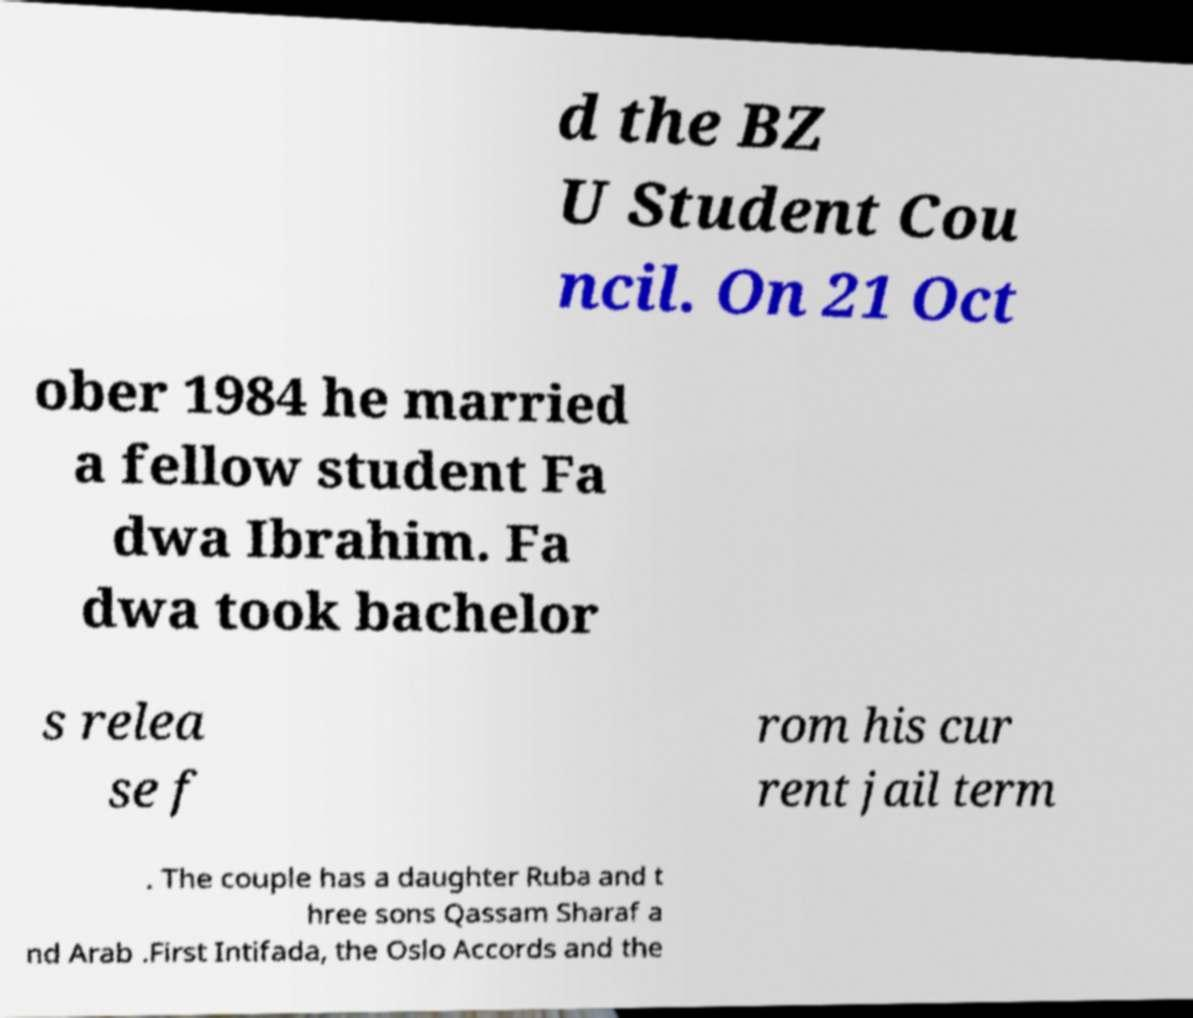Could you assist in decoding the text presented in this image and type it out clearly? d the BZ U Student Cou ncil. On 21 Oct ober 1984 he married a fellow student Fa dwa Ibrahim. Fa dwa took bachelor s relea se f rom his cur rent jail term . The couple has a daughter Ruba and t hree sons Qassam Sharaf a nd Arab .First Intifada, the Oslo Accords and the 